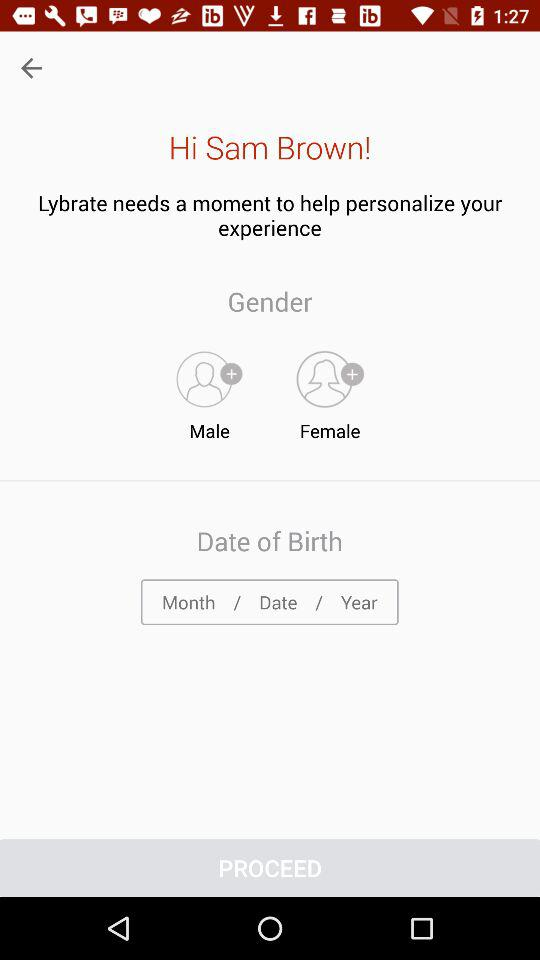What is the user name? The user name is Sam Brown. 